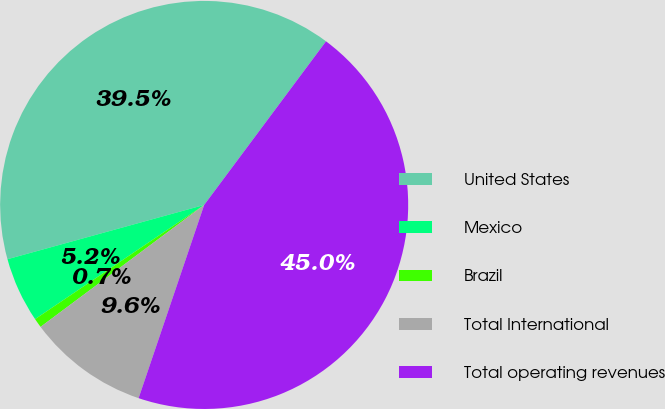<chart> <loc_0><loc_0><loc_500><loc_500><pie_chart><fcel>United States<fcel>Mexico<fcel>Brazil<fcel>Total International<fcel>Total operating revenues<nl><fcel>39.47%<fcel>5.17%<fcel>0.74%<fcel>9.6%<fcel>45.02%<nl></chart> 